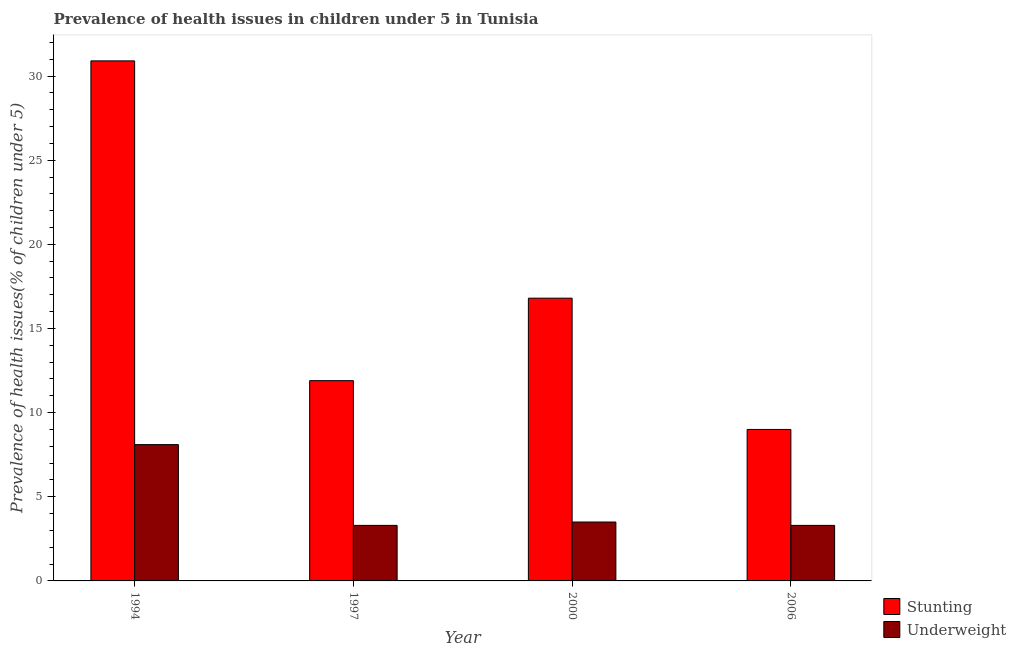How many groups of bars are there?
Your response must be concise. 4. What is the label of the 2nd group of bars from the left?
Give a very brief answer. 1997. What is the percentage of underweight children in 2000?
Offer a very short reply. 3.5. Across all years, what is the maximum percentage of stunted children?
Offer a very short reply. 30.9. Across all years, what is the minimum percentage of underweight children?
Offer a terse response. 3.3. In which year was the percentage of underweight children minimum?
Your answer should be very brief. 1997. What is the total percentage of stunted children in the graph?
Offer a very short reply. 68.6. What is the difference between the percentage of stunted children in 1994 and that in 2000?
Your answer should be compact. 14.1. What is the difference between the percentage of underweight children in 1997 and the percentage of stunted children in 2000?
Offer a terse response. -0.2. What is the average percentage of stunted children per year?
Give a very brief answer. 17.15. In the year 2006, what is the difference between the percentage of stunted children and percentage of underweight children?
Ensure brevity in your answer.  0. In how many years, is the percentage of underweight children greater than 3 %?
Give a very brief answer. 4. What is the ratio of the percentage of stunted children in 1997 to that in 2000?
Keep it short and to the point. 0.71. Is the percentage of underweight children in 1997 less than that in 2000?
Offer a very short reply. Yes. What is the difference between the highest and the second highest percentage of stunted children?
Keep it short and to the point. 14.1. What is the difference between the highest and the lowest percentage of stunted children?
Offer a terse response. 21.9. What does the 1st bar from the left in 1994 represents?
Your response must be concise. Stunting. What does the 1st bar from the right in 1994 represents?
Provide a short and direct response. Underweight. Are all the bars in the graph horizontal?
Your response must be concise. No. How many years are there in the graph?
Ensure brevity in your answer.  4. What is the difference between two consecutive major ticks on the Y-axis?
Give a very brief answer. 5. Are the values on the major ticks of Y-axis written in scientific E-notation?
Your answer should be compact. No. Where does the legend appear in the graph?
Your answer should be compact. Bottom right. How many legend labels are there?
Ensure brevity in your answer.  2. How are the legend labels stacked?
Keep it short and to the point. Vertical. What is the title of the graph?
Ensure brevity in your answer.  Prevalence of health issues in children under 5 in Tunisia. What is the label or title of the Y-axis?
Make the answer very short. Prevalence of health issues(% of children under 5). What is the Prevalence of health issues(% of children under 5) in Stunting in 1994?
Give a very brief answer. 30.9. What is the Prevalence of health issues(% of children under 5) of Underweight in 1994?
Provide a short and direct response. 8.1. What is the Prevalence of health issues(% of children under 5) in Stunting in 1997?
Make the answer very short. 11.9. What is the Prevalence of health issues(% of children under 5) of Underweight in 1997?
Offer a very short reply. 3.3. What is the Prevalence of health issues(% of children under 5) in Stunting in 2000?
Provide a succinct answer. 16.8. What is the Prevalence of health issues(% of children under 5) of Underweight in 2000?
Provide a succinct answer. 3.5. What is the Prevalence of health issues(% of children under 5) in Underweight in 2006?
Offer a terse response. 3.3. Across all years, what is the maximum Prevalence of health issues(% of children under 5) of Stunting?
Your answer should be very brief. 30.9. Across all years, what is the maximum Prevalence of health issues(% of children under 5) of Underweight?
Offer a very short reply. 8.1. Across all years, what is the minimum Prevalence of health issues(% of children under 5) in Underweight?
Offer a terse response. 3.3. What is the total Prevalence of health issues(% of children under 5) in Stunting in the graph?
Offer a terse response. 68.6. What is the difference between the Prevalence of health issues(% of children under 5) of Stunting in 1994 and that in 1997?
Keep it short and to the point. 19. What is the difference between the Prevalence of health issues(% of children under 5) in Stunting in 1994 and that in 2006?
Provide a short and direct response. 21.9. What is the difference between the Prevalence of health issues(% of children under 5) of Stunting in 1997 and that in 2000?
Your answer should be compact. -4.9. What is the difference between the Prevalence of health issues(% of children under 5) of Underweight in 1997 and that in 2000?
Make the answer very short. -0.2. What is the difference between the Prevalence of health issues(% of children under 5) in Stunting in 1997 and that in 2006?
Your response must be concise. 2.9. What is the difference between the Prevalence of health issues(% of children under 5) of Underweight in 1997 and that in 2006?
Your response must be concise. 0. What is the difference between the Prevalence of health issues(% of children under 5) in Stunting in 2000 and that in 2006?
Offer a terse response. 7.8. What is the difference between the Prevalence of health issues(% of children under 5) of Stunting in 1994 and the Prevalence of health issues(% of children under 5) of Underweight in 1997?
Provide a succinct answer. 27.6. What is the difference between the Prevalence of health issues(% of children under 5) of Stunting in 1994 and the Prevalence of health issues(% of children under 5) of Underweight in 2000?
Keep it short and to the point. 27.4. What is the difference between the Prevalence of health issues(% of children under 5) in Stunting in 1994 and the Prevalence of health issues(% of children under 5) in Underweight in 2006?
Keep it short and to the point. 27.6. What is the difference between the Prevalence of health issues(% of children under 5) in Stunting in 2000 and the Prevalence of health issues(% of children under 5) in Underweight in 2006?
Provide a short and direct response. 13.5. What is the average Prevalence of health issues(% of children under 5) in Stunting per year?
Give a very brief answer. 17.15. What is the average Prevalence of health issues(% of children under 5) in Underweight per year?
Provide a succinct answer. 4.55. In the year 1994, what is the difference between the Prevalence of health issues(% of children under 5) in Stunting and Prevalence of health issues(% of children under 5) in Underweight?
Keep it short and to the point. 22.8. In the year 2000, what is the difference between the Prevalence of health issues(% of children under 5) in Stunting and Prevalence of health issues(% of children under 5) in Underweight?
Your answer should be compact. 13.3. In the year 2006, what is the difference between the Prevalence of health issues(% of children under 5) of Stunting and Prevalence of health issues(% of children under 5) of Underweight?
Keep it short and to the point. 5.7. What is the ratio of the Prevalence of health issues(% of children under 5) in Stunting in 1994 to that in 1997?
Offer a very short reply. 2.6. What is the ratio of the Prevalence of health issues(% of children under 5) in Underweight in 1994 to that in 1997?
Keep it short and to the point. 2.45. What is the ratio of the Prevalence of health issues(% of children under 5) in Stunting in 1994 to that in 2000?
Give a very brief answer. 1.84. What is the ratio of the Prevalence of health issues(% of children under 5) of Underweight in 1994 to that in 2000?
Offer a terse response. 2.31. What is the ratio of the Prevalence of health issues(% of children under 5) of Stunting in 1994 to that in 2006?
Ensure brevity in your answer.  3.43. What is the ratio of the Prevalence of health issues(% of children under 5) in Underweight in 1994 to that in 2006?
Provide a succinct answer. 2.45. What is the ratio of the Prevalence of health issues(% of children under 5) of Stunting in 1997 to that in 2000?
Provide a short and direct response. 0.71. What is the ratio of the Prevalence of health issues(% of children under 5) in Underweight in 1997 to that in 2000?
Your answer should be compact. 0.94. What is the ratio of the Prevalence of health issues(% of children under 5) of Stunting in 1997 to that in 2006?
Make the answer very short. 1.32. What is the ratio of the Prevalence of health issues(% of children under 5) in Underweight in 1997 to that in 2006?
Your answer should be compact. 1. What is the ratio of the Prevalence of health issues(% of children under 5) in Stunting in 2000 to that in 2006?
Keep it short and to the point. 1.87. What is the ratio of the Prevalence of health issues(% of children under 5) of Underweight in 2000 to that in 2006?
Give a very brief answer. 1.06. What is the difference between the highest and the second highest Prevalence of health issues(% of children under 5) of Underweight?
Your answer should be very brief. 4.6. What is the difference between the highest and the lowest Prevalence of health issues(% of children under 5) of Stunting?
Make the answer very short. 21.9. What is the difference between the highest and the lowest Prevalence of health issues(% of children under 5) of Underweight?
Keep it short and to the point. 4.8. 